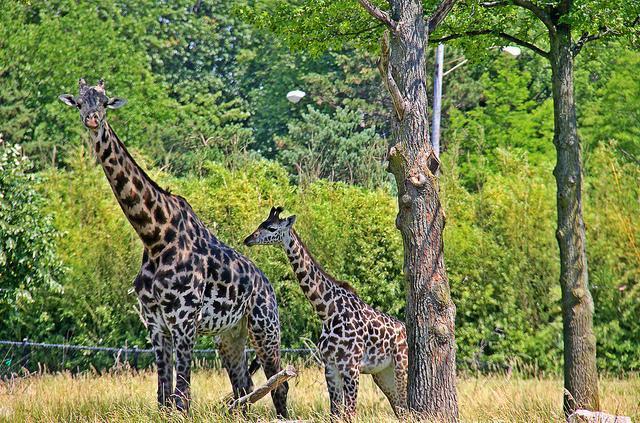How many giraffes can be seen?
Give a very brief answer. 2. 